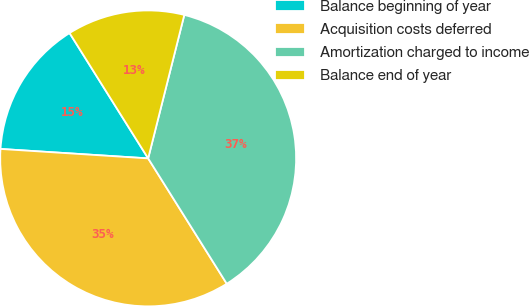<chart> <loc_0><loc_0><loc_500><loc_500><pie_chart><fcel>Balance beginning of year<fcel>Acquisition costs deferred<fcel>Amortization charged to income<fcel>Balance end of year<nl><fcel>15.07%<fcel>34.93%<fcel>37.16%<fcel>12.84%<nl></chart> 